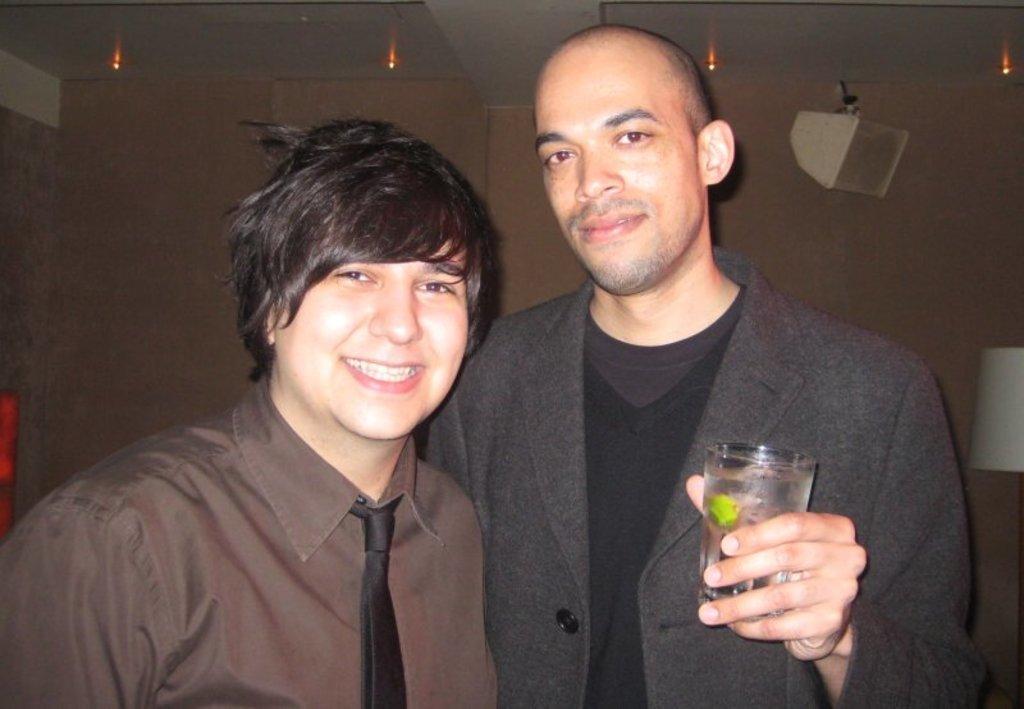Could you give a brief overview of what you see in this image? In the picture we can see two persons wearing brown and black color dress respectively, person wearing black color dress holding glass in his hands and in the background there is a wall. 